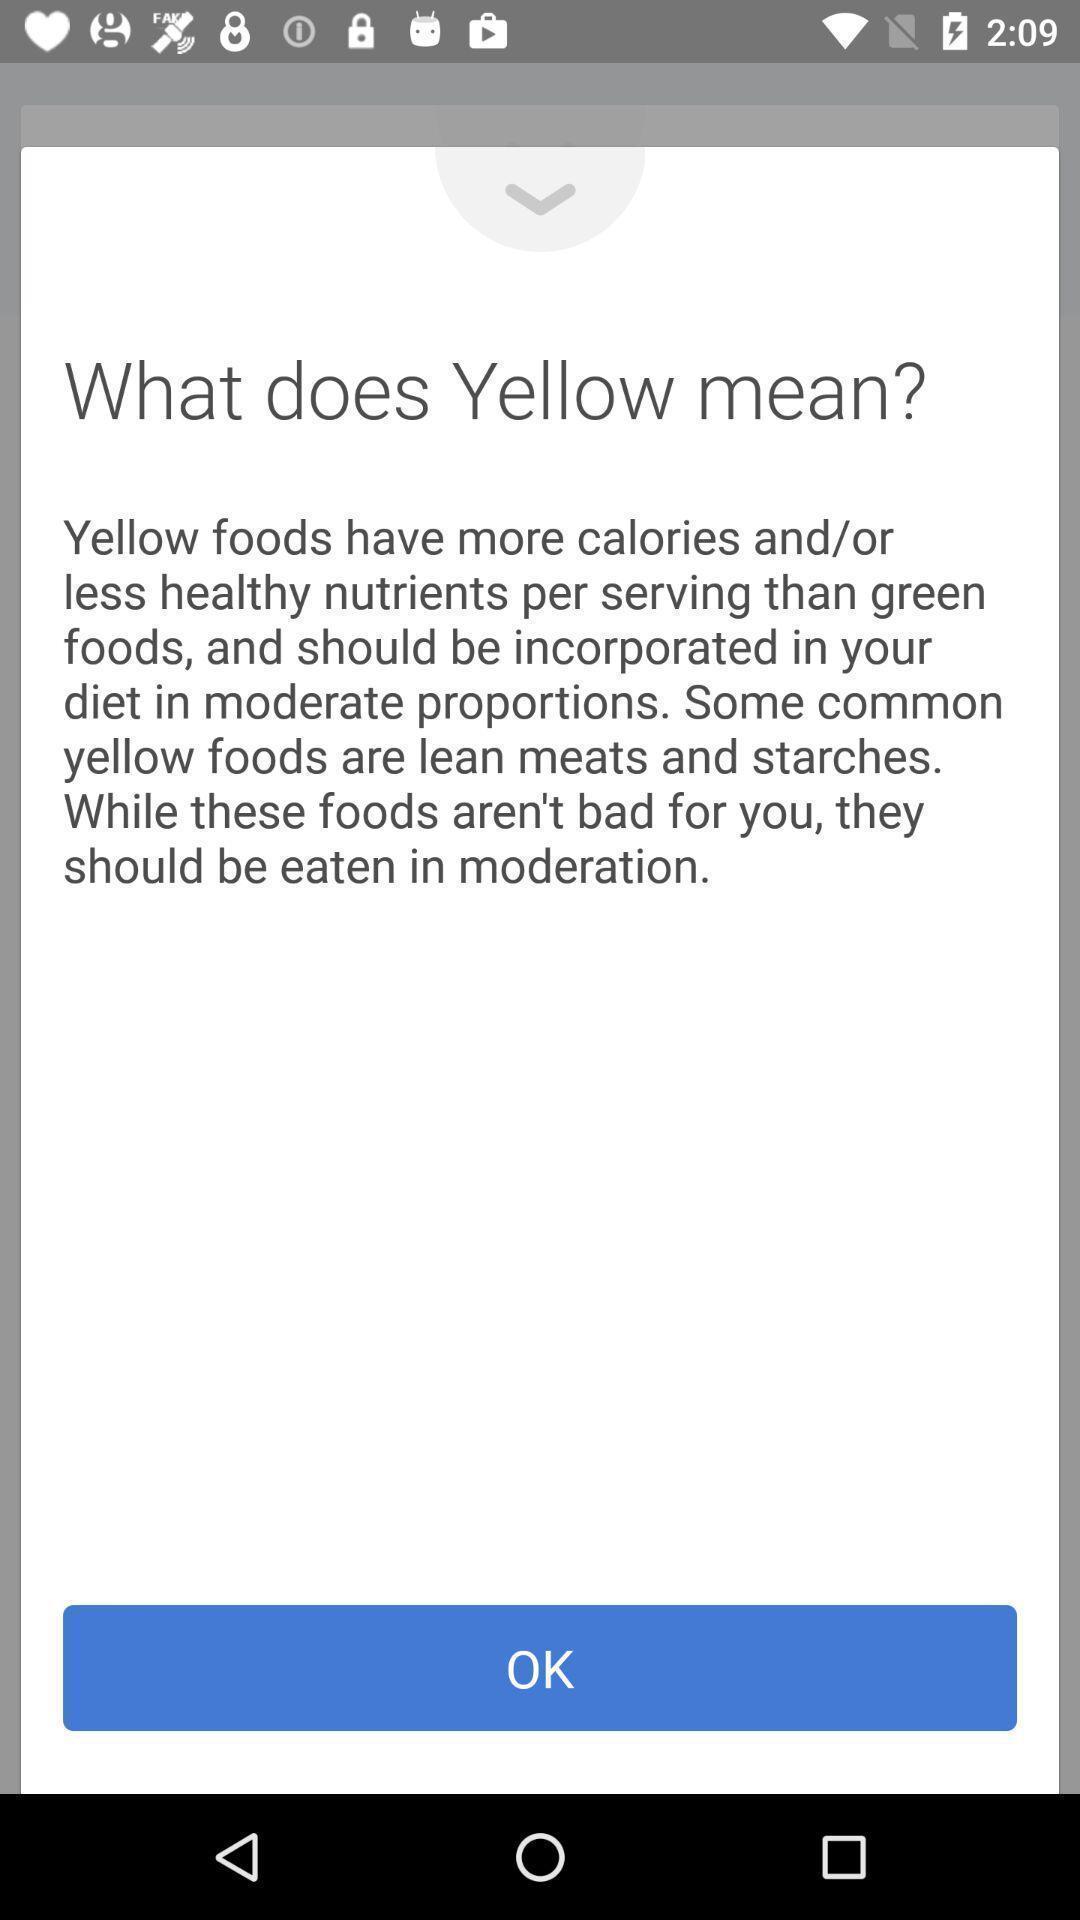Summarize the main components in this picture. Page showing information about yellow foods. 